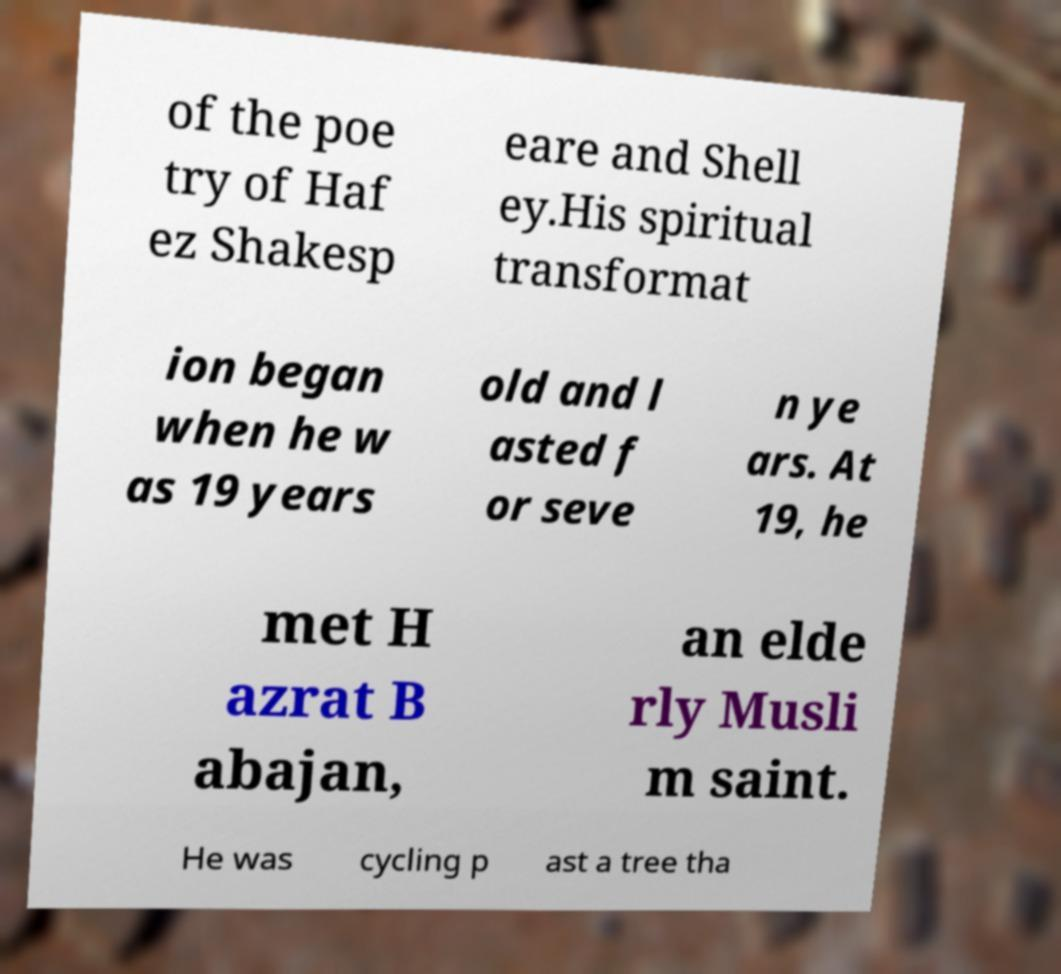I need the written content from this picture converted into text. Can you do that? of the poe try of Haf ez Shakesp eare and Shell ey.His spiritual transformat ion began when he w as 19 years old and l asted f or seve n ye ars. At 19, he met H azrat B abajan, an elde rly Musli m saint. He was cycling p ast a tree tha 